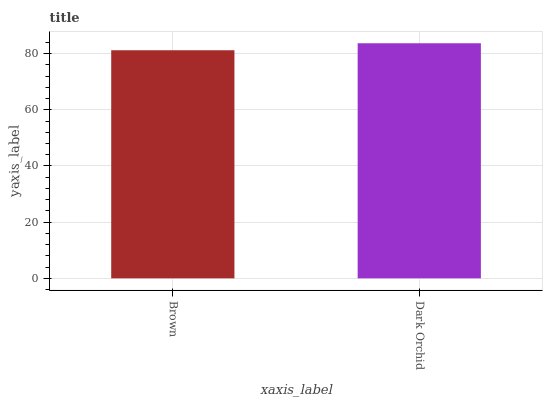Is Brown the minimum?
Answer yes or no. Yes. Is Dark Orchid the maximum?
Answer yes or no. Yes. Is Dark Orchid the minimum?
Answer yes or no. No. Is Dark Orchid greater than Brown?
Answer yes or no. Yes. Is Brown less than Dark Orchid?
Answer yes or no. Yes. Is Brown greater than Dark Orchid?
Answer yes or no. No. Is Dark Orchid less than Brown?
Answer yes or no. No. Is Dark Orchid the high median?
Answer yes or no. Yes. Is Brown the low median?
Answer yes or no. Yes. Is Brown the high median?
Answer yes or no. No. Is Dark Orchid the low median?
Answer yes or no. No. 